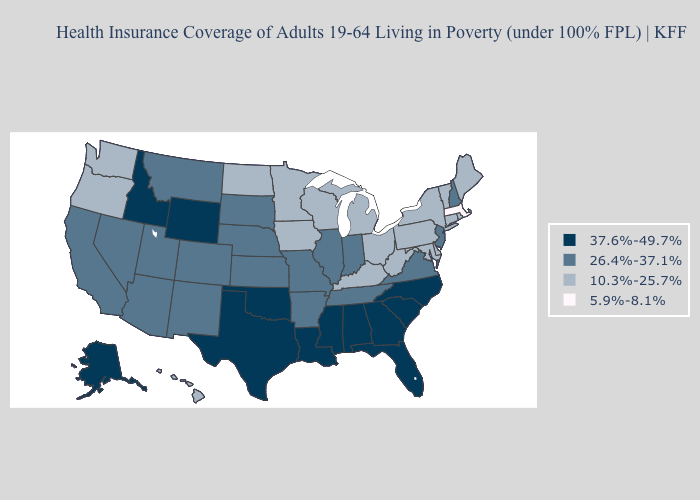What is the value of Texas?
Concise answer only. 37.6%-49.7%. What is the lowest value in states that border Delaware?
Keep it brief. 10.3%-25.7%. Name the states that have a value in the range 37.6%-49.7%?
Quick response, please. Alabama, Alaska, Florida, Georgia, Idaho, Louisiana, Mississippi, North Carolina, Oklahoma, South Carolina, Texas, Wyoming. Which states have the lowest value in the Northeast?
Concise answer only. Massachusetts. Does Washington have the same value as Indiana?
Quick response, please. No. Name the states that have a value in the range 5.9%-8.1%?
Answer briefly. Massachusetts. What is the value of Connecticut?
Short answer required. 10.3%-25.7%. Which states have the highest value in the USA?
Quick response, please. Alabama, Alaska, Florida, Georgia, Idaho, Louisiana, Mississippi, North Carolina, Oklahoma, South Carolina, Texas, Wyoming. What is the value of Delaware?
Quick response, please. 10.3%-25.7%. Does Montana have the same value as Kansas?
Concise answer only. Yes. What is the lowest value in the USA?
Write a very short answer. 5.9%-8.1%. Which states have the highest value in the USA?
Give a very brief answer. Alabama, Alaska, Florida, Georgia, Idaho, Louisiana, Mississippi, North Carolina, Oklahoma, South Carolina, Texas, Wyoming. Is the legend a continuous bar?
Give a very brief answer. No. What is the highest value in states that border Virginia?
Answer briefly. 37.6%-49.7%. 